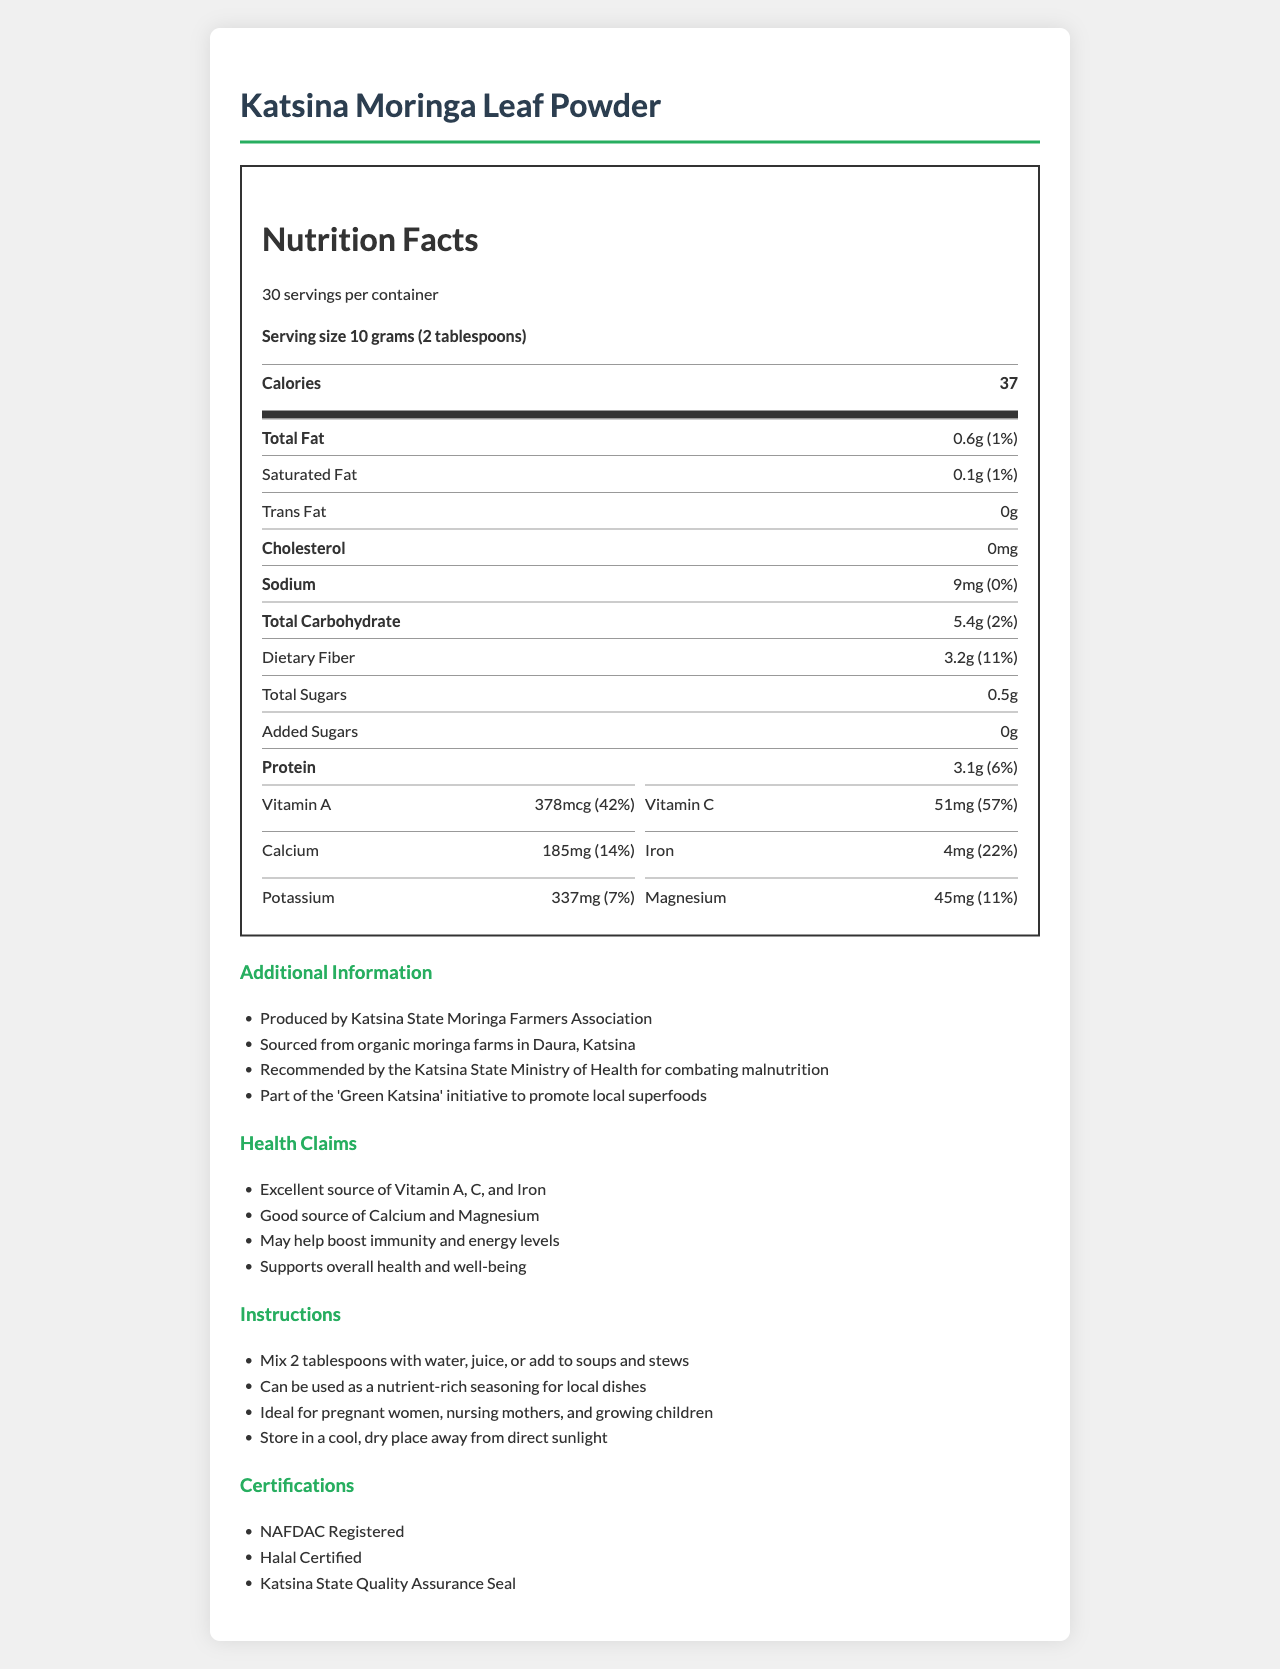what is the serving size of Katsina Moringa Leaf Powder? The serving size is clearly mentioned at the top of the nutrition section.
Answer: 10 grams (2 tablespoons) how many servings are there per container? The document states that there are 30 servings per container.
Answer: 30 how many calories are in one serving of Moringa Leaf Powder? The number of calories per serving is highlighted in the nutrition facts.
Answer: 37 how much total fat is present in one serving? The total fat content per serving is listed in the nutrition facts section as 0.6 grams.
Answer: 0.6g what percentage of the daily value of Vitamin C does one serving provide? The daily value percentage of Vitamin C in one serving is given as 57%.
Answer: 57% what vitamins and minerals are listed for the Moringa Leaf Powder? These specific vitamins and minerals are enumerated in the vitamins and minerals section.
Answer: Vitamin A, Vitamin C, Calcium, Iron, Potassium, Magnesium which organization recommends Katsina Moringa Leaf Powder for combating malnutrition? This information is provided in the additional information section, where it mentions that the product is recommended by the Katsina State Ministry of Health.
Answer: Katsina State Ministry of Health what is the suggested use for pregnant women and nursing mothers? The instructions mention that the product is ideal for these specific groups.
Answer: Ideal for pregnant women, nursing mothers, and growing children how much protein does one serving contain? The protein content per serving is 3.1 grams, as shown in the nutrition facts section.
Answer: 3.1g what percentage of daily Iron does one serving provide? The iron content per serving provides 22% of the daily value, as stated in the vitamins and minerals section.
Answer: 22% how much dietary fiber is in one serving of the powder? The dietary fiber content per serving is 3.2 grams, provided in the nutrition facts.
Answer: 3.2g which nutrient in Katsina Moringa Leaf Powder contributes the highest daily percentage value? A. Calcium B. Vitamin A C. Iron D. Vitamin C The daily value percentages listed show that Vitamin C has the highest daily percentage value at 57%.
Answer: D. Vitamin C which of the following health claims is mentioned in the document? A. Supports muscle growth B. May help boost immunity and energy levels C. Enhances vision D. Reduces stress This health claim is explicitly listed under the health claims section.
Answer: B. May help boost immunity and energy levels Is the product halal certified? The document states that the product is Halal Certified in the certifications section.
Answer: Yes Can the document provide information on how to grow Moringa? The document focuses on the nutrition facts and usage instructions for the product but does not provide any information on growing Moringa.
Answer: Not enough information What is the main purpose of the document? The document comprehensively covers nutritional values, health claims, usage instructions, and certifications to underscore the benefits and quality of Katsina Moringa Leaf Powder.
Answer: To provide detailed nutritional information about Katsina Moringa Leaf Powder, its health benefits, recommended usage, and certifications, particularly in the context of its potential to address malnutrition in the region. 